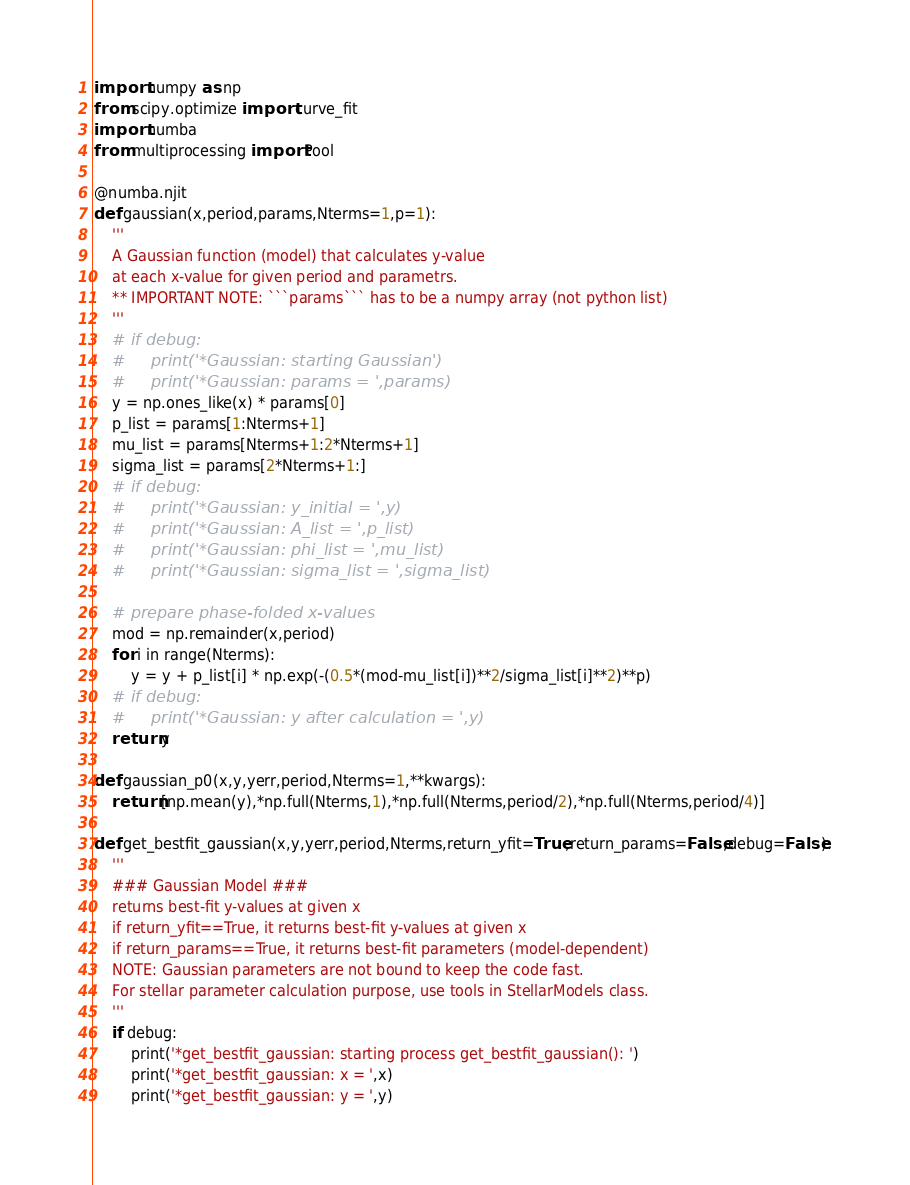Convert code to text. <code><loc_0><loc_0><loc_500><loc_500><_Python_>import numpy as np
from scipy.optimize import curve_fit
import numba
from multiprocessing import Pool

@numba.njit
def gaussian(x,period,params,Nterms=1,p=1):
    '''
    A Gaussian function (model) that calculates y-value 
    at each x-value for given period and parametrs.
    ** IMPORTANT NOTE: ```params``` has to be a numpy array (not python list)
    '''
    # if debug:
    #     print('*Gaussian: starting Gaussian')
    #     print('*Gaussian: params = ',params)
    y = np.ones_like(x) * params[0]
    p_list = params[1:Nterms+1]
    mu_list = params[Nterms+1:2*Nterms+1]
    sigma_list = params[2*Nterms+1:]
    # if debug:
    #     print('*Gaussian: y_initial = ',y)
    #     print('*Gaussian: A_list = ',p_list)
    #     print('*Gaussian: phi_list = ',mu_list)
    #     print('*Gaussian: sigma_list = ',sigma_list)

    # prepare phase-folded x-values
    mod = np.remainder(x,period)
    for i in range(Nterms):
        y = y + p_list[i] * np.exp(-(0.5*(mod-mu_list[i])**2/sigma_list[i]**2)**p)
    # if debug:
    #     print('*Gaussian: y after calculation = ',y)
    return y

def gaussian_p0(x,y,yerr,period,Nterms=1,**kwargs):
    return [np.mean(y),*np.full(Nterms,1),*np.full(Nterms,period/2),*np.full(Nterms,period/4)]

def get_bestfit_gaussian(x,y,yerr,period,Nterms,return_yfit=True,return_params=False,debug=False):
    '''
    ### Gaussian Model ###
    returns best-fit y-values at given x
    if return_yfit==True, it returns best-fit y-values at given x
    if return_params==True, it returns best-fit parameters (model-dependent)
    NOTE: Gaussian parameters are not bound to keep the code fast.
    For stellar parameter calculation purpose, use tools in StellarModels class.
    '''
    if debug:
        print('*get_bestfit_gaussian: starting process get_bestfit_gaussian(): ')
        print('*get_bestfit_gaussian: x = ',x)
        print('*get_bestfit_gaussian: y = ',y)</code> 